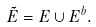<formula> <loc_0><loc_0><loc_500><loc_500>\tilde { E } = E \cup E ^ { b } .</formula> 